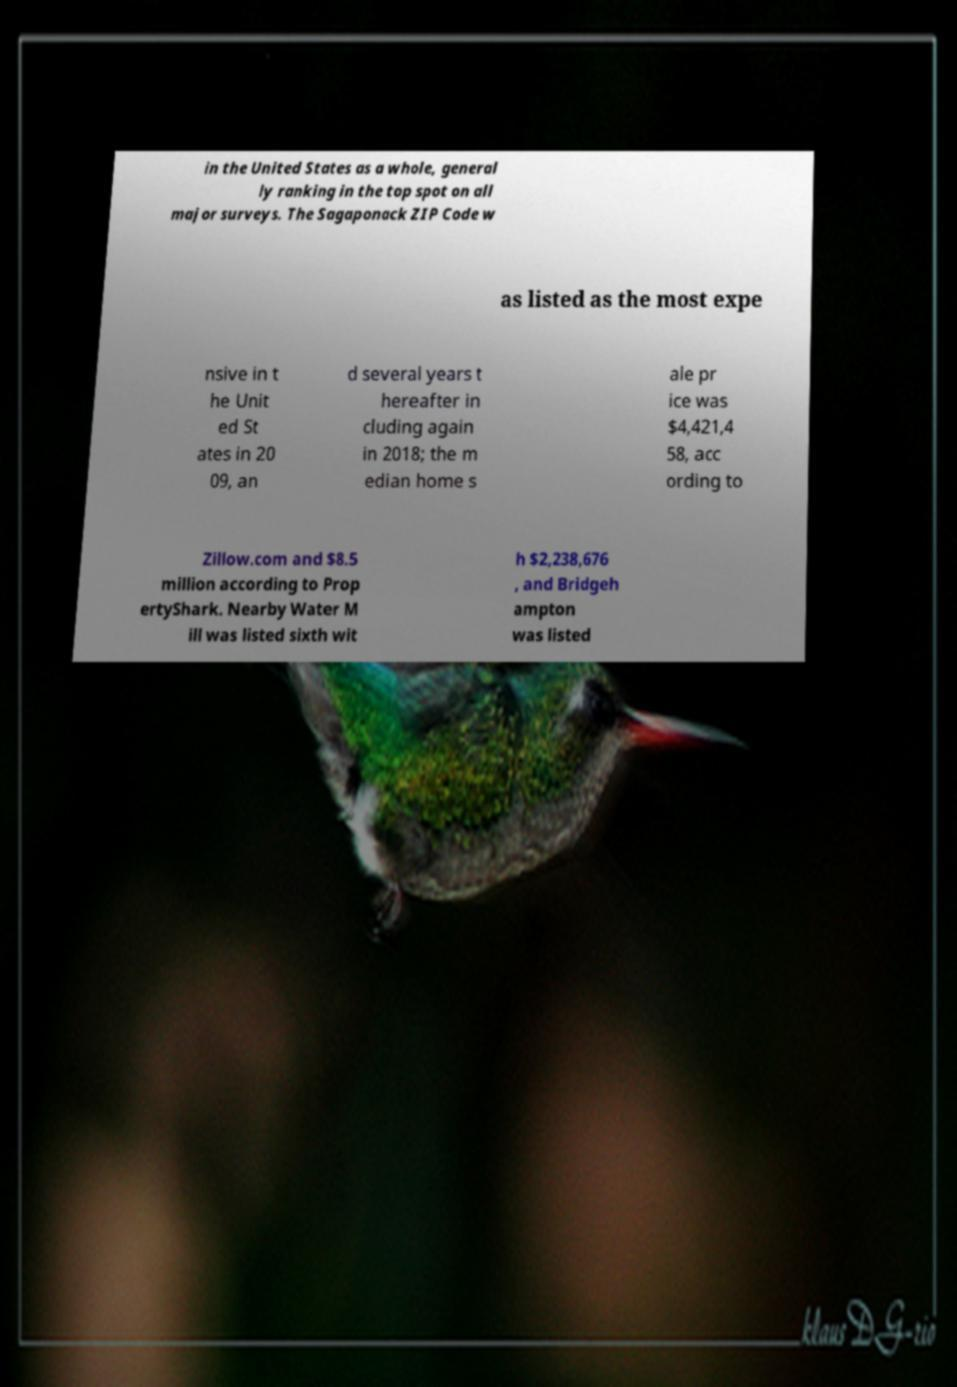Could you assist in decoding the text presented in this image and type it out clearly? in the United States as a whole, general ly ranking in the top spot on all major surveys. The Sagaponack ZIP Code w as listed as the most expe nsive in t he Unit ed St ates in 20 09, an d several years t hereafter in cluding again in 2018; the m edian home s ale pr ice was $4,421,4 58, acc ording to Zillow.com and $8.5 million according to Prop ertyShark. Nearby Water M ill was listed sixth wit h $2,238,676 , and Bridgeh ampton was listed 